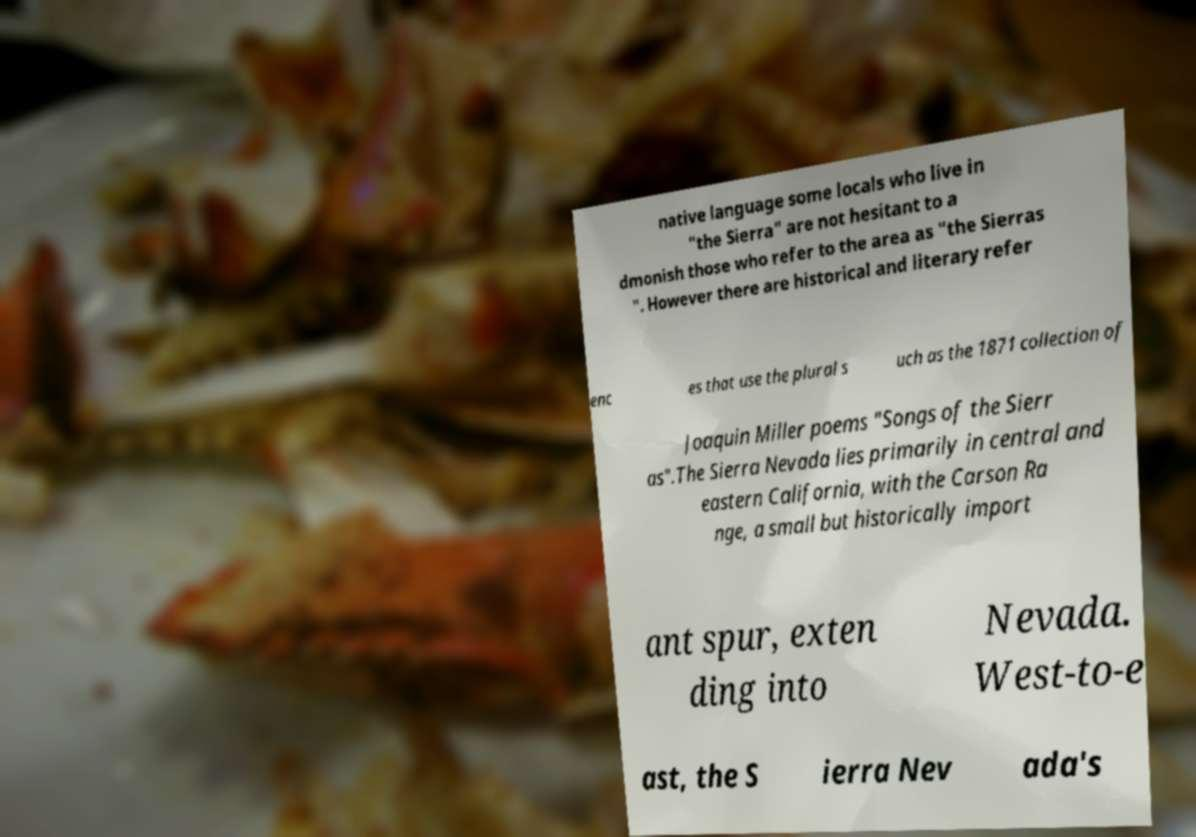Could you extract and type out the text from this image? native language some locals who live in "the Sierra" are not hesitant to a dmonish those who refer to the area as "the Sierras ". However there are historical and literary refer enc es that use the plural s uch as the 1871 collection of Joaquin Miller poems "Songs of the Sierr as".The Sierra Nevada lies primarily in central and eastern California, with the Carson Ra nge, a small but historically import ant spur, exten ding into Nevada. West-to-e ast, the S ierra Nev ada's 